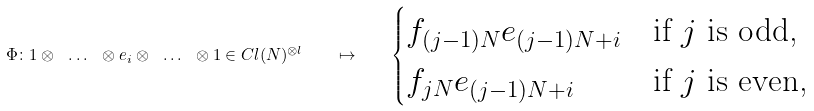<formula> <loc_0><loc_0><loc_500><loc_500>\Phi \colon 1 \otimes \ \dots \ \otimes e _ { i } \otimes \ \dots \ \otimes 1 \in C l ( N ) ^ { \otimes l } \quad \mapsto \quad \begin{cases} f _ { ( j - 1 ) N } e _ { ( j - 1 ) N + i } & \text {if $j$ is odd,} \\ f _ { j N } e _ { ( j - 1 ) N + i } & \text {if $j$ is even,} \end{cases}</formula> 